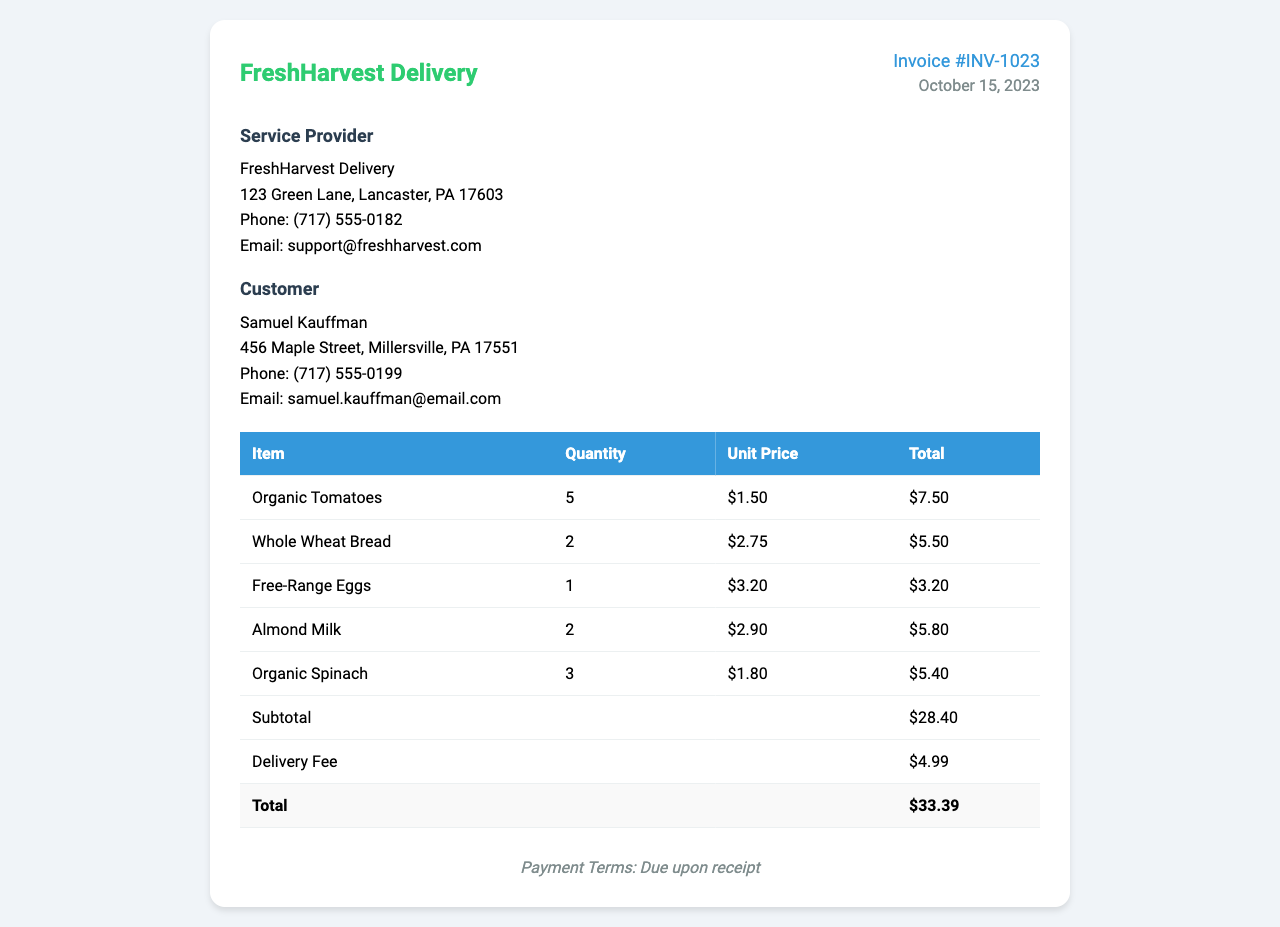what is the invoice number? The invoice number is listed at the top right of the document, labeled as Invoice #INV-1023.
Answer: Invoice #INV-1023 who is the service provider? The service provider is mentioned in the section labeled "Service Provider." It states FreshHarvest Delivery.
Answer: FreshHarvest Delivery what is the delivery fee? The delivery fee is listed in the table among other financial details, which is $4.99.
Answer: $4.99 how many Organic Tomatoes were purchased? The quantity of Organic Tomatoes is provided in the table, showing that 5 were purchased.
Answer: 5 what is the total cost including delivery? The total cost is displayed at the end of the financial table, which is $33.39.
Answer: $33.39 who is the customer? The customer information is listed under the "Customer" section, stating Samuel Kauffman.
Answer: Samuel Kauffman what date was the invoice issued? The invoice date is found adjacent to the invoice number, noted as October 15, 2023.
Answer: October 15, 2023 how many items are listed in the invoice? The total number of items purchased can be counted from the table, amounting to 5 items.
Answer: 5 items what are the payment terms? The payment terms are provided at the end of the invoice, indicating the payment is due upon receipt.
Answer: Due upon receipt 